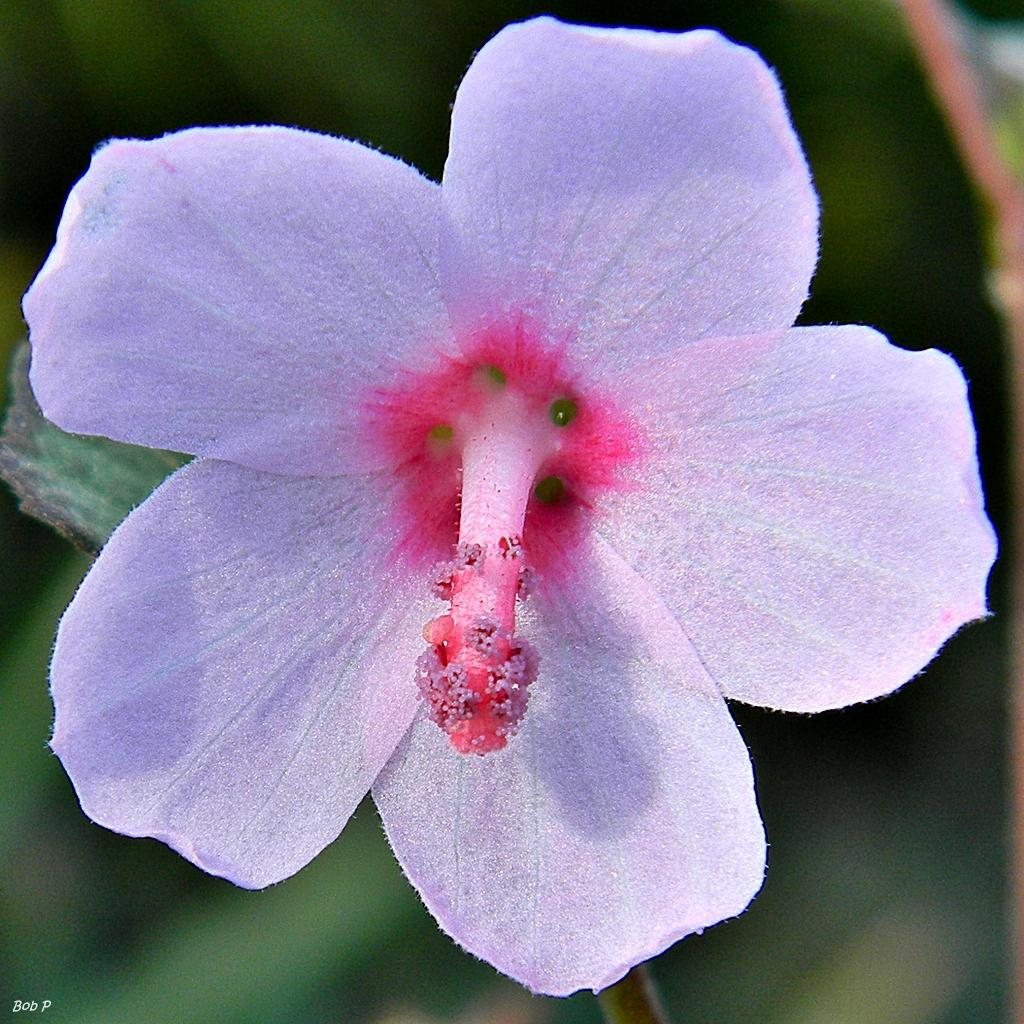What is the main subject of the image? There is a flower in the image. Can you describe the colors of the flower? The flower has pink and white colors. Is the flower part of a larger plant? Yes, the flower is attached to a plant. What is the color of the plant? The plant has a green color. Are there any other plants visible in the image? Yes, there is a green colored plant in the background of the image. What type of punishment is being given to the flower in the image? There is no punishment being given to the flower in the image; it is simply a flower attached to a plant. How does the brake of the flower work in the image? There is no brake present in the image, as it is a flower attached to a plant and not a vehicle or machine. 